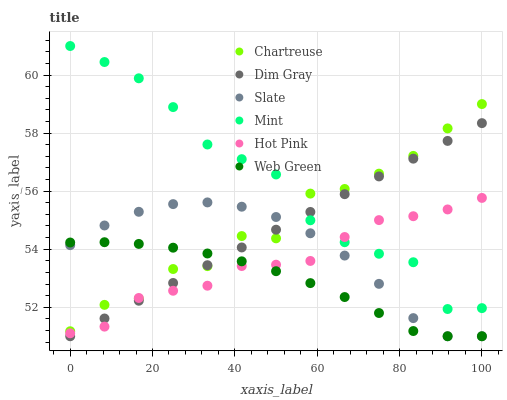Does Web Green have the minimum area under the curve?
Answer yes or no. Yes. Does Mint have the maximum area under the curve?
Answer yes or no. Yes. Does Slate have the minimum area under the curve?
Answer yes or no. No. Does Slate have the maximum area under the curve?
Answer yes or no. No. Is Dim Gray the smoothest?
Answer yes or no. Yes. Is Chartreuse the roughest?
Answer yes or no. Yes. Is Slate the smoothest?
Answer yes or no. No. Is Slate the roughest?
Answer yes or no. No. Does Dim Gray have the lowest value?
Answer yes or no. Yes. Does Hot Pink have the lowest value?
Answer yes or no. No. Does Mint have the highest value?
Answer yes or no. Yes. Does Slate have the highest value?
Answer yes or no. No. Is Slate less than Mint?
Answer yes or no. Yes. Is Mint greater than Slate?
Answer yes or no. Yes. Does Slate intersect Dim Gray?
Answer yes or no. Yes. Is Slate less than Dim Gray?
Answer yes or no. No. Is Slate greater than Dim Gray?
Answer yes or no. No. Does Slate intersect Mint?
Answer yes or no. No. 